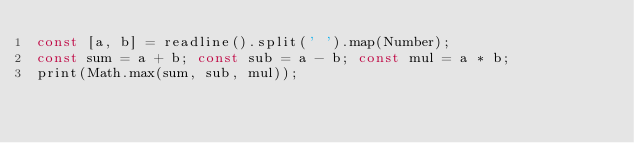<code> <loc_0><loc_0><loc_500><loc_500><_JavaScript_>const [a, b] = readline().split(' ').map(Number);
const sum = a + b; const sub = a - b; const mul = a * b;
print(Math.max(sum, sub, mul));
</code> 